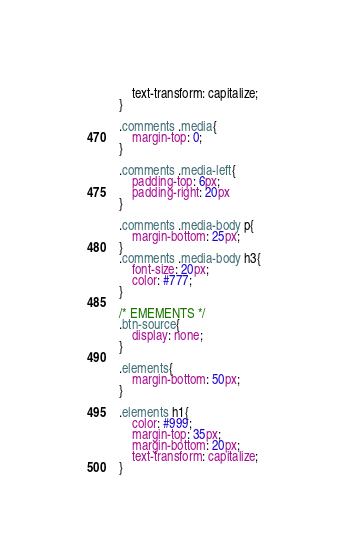<code> <loc_0><loc_0><loc_500><loc_500><_CSS_>	text-transform: capitalize;
}

.comments .media{
	margin-top: 0;
}

.comments .media-left{
	padding-top: 6px; 
	padding-right: 20px
}

.comments .media-body p{
	margin-bottom: 25px;
}
.comments .media-body h3{
	font-size: 20px;
	color: #777;
}

/* EMEMENTS */
.btn-source{
	display: none;
}

.elements{
	margin-bottom: 50px;
}

.elements h1{
	color: #999;
	margin-top: 35px;
	margin-bottom: 20px;
	text-transform: capitalize;
}</code> 